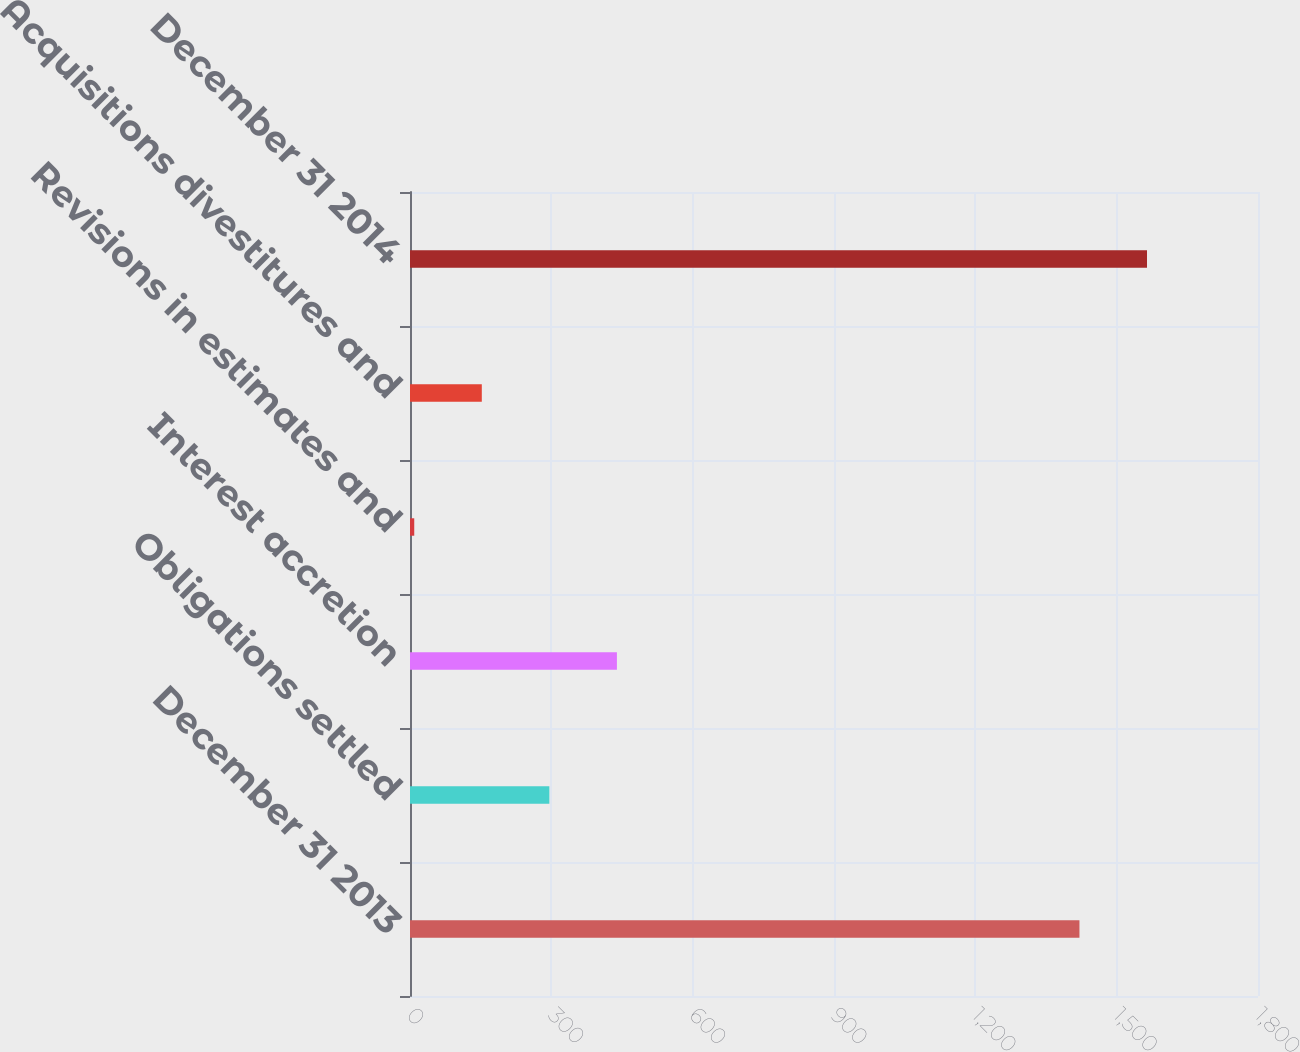Convert chart. <chart><loc_0><loc_0><loc_500><loc_500><bar_chart><fcel>December 31 2013<fcel>Obligations settled<fcel>Interest accretion<fcel>Revisions in estimates and<fcel>Acquisitions divestitures and<fcel>December 31 2014<nl><fcel>1421<fcel>295.8<fcel>439.2<fcel>9<fcel>152.4<fcel>1564.4<nl></chart> 